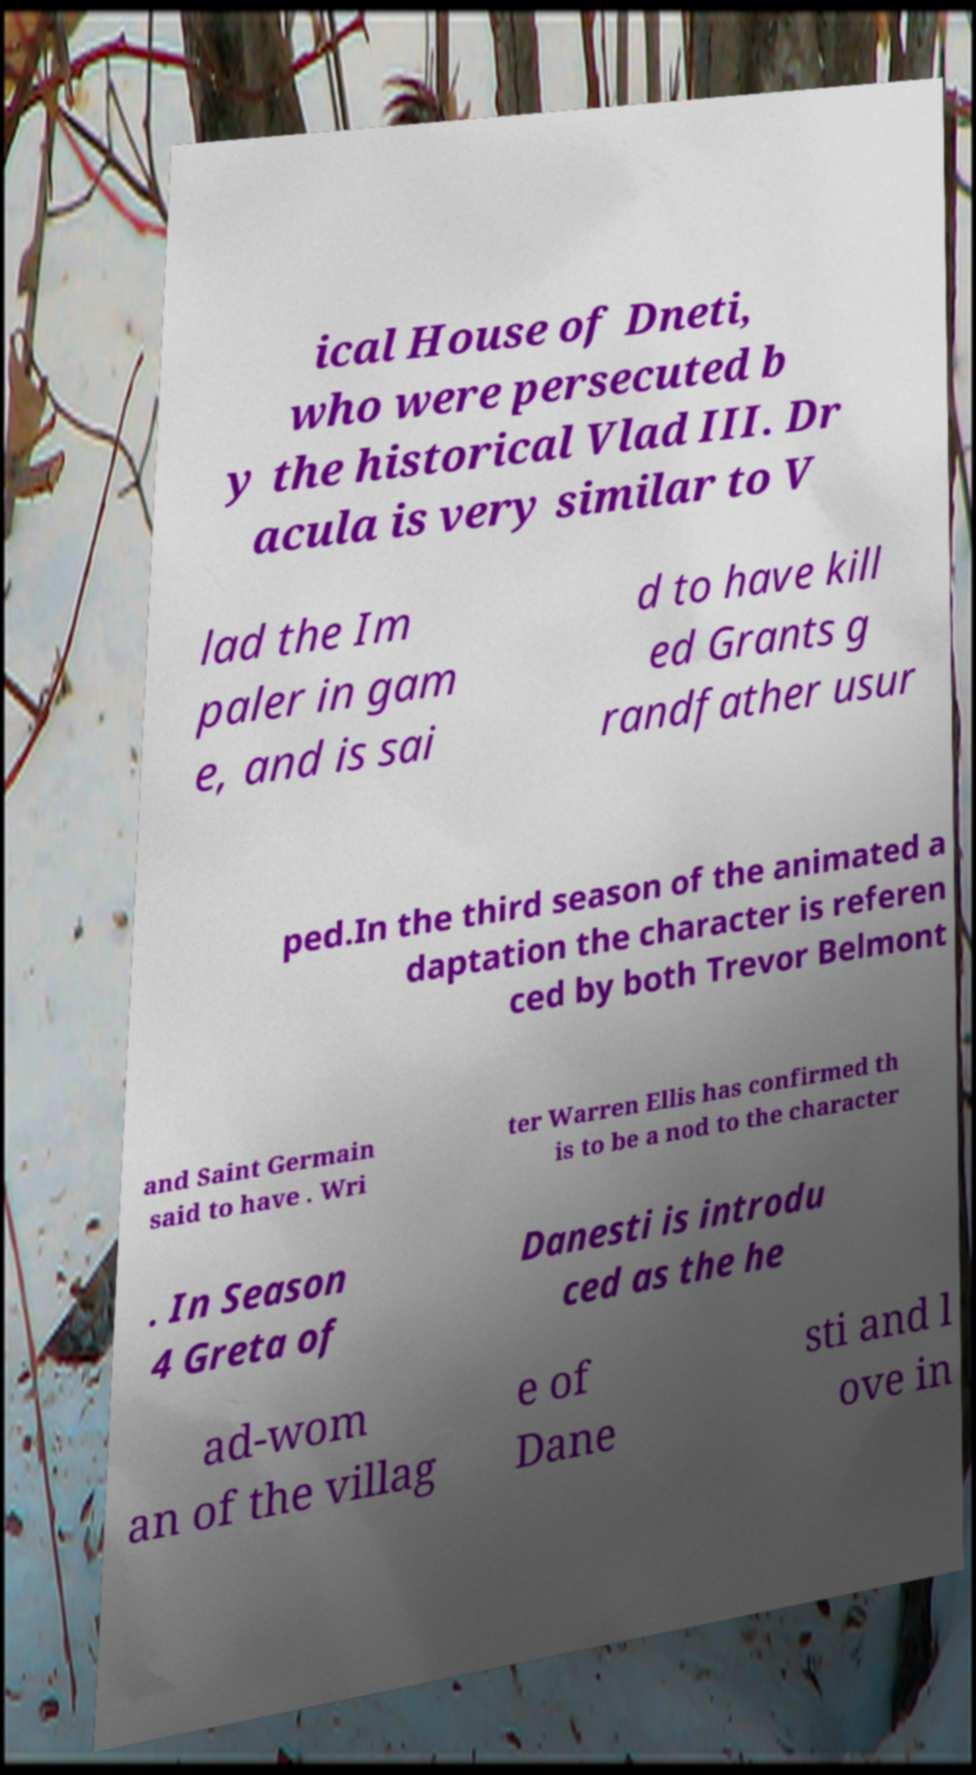Can you accurately transcribe the text from the provided image for me? ical House of Dneti, who were persecuted b y the historical Vlad III. Dr acula is very similar to V lad the Im paler in gam e, and is sai d to have kill ed Grants g randfather usur ped.In the third season of the animated a daptation the character is referen ced by both Trevor Belmont and Saint Germain said to have . Wri ter Warren Ellis has confirmed th is to be a nod to the character . In Season 4 Greta of Danesti is introdu ced as the he ad-wom an of the villag e of Dane sti and l ove in 